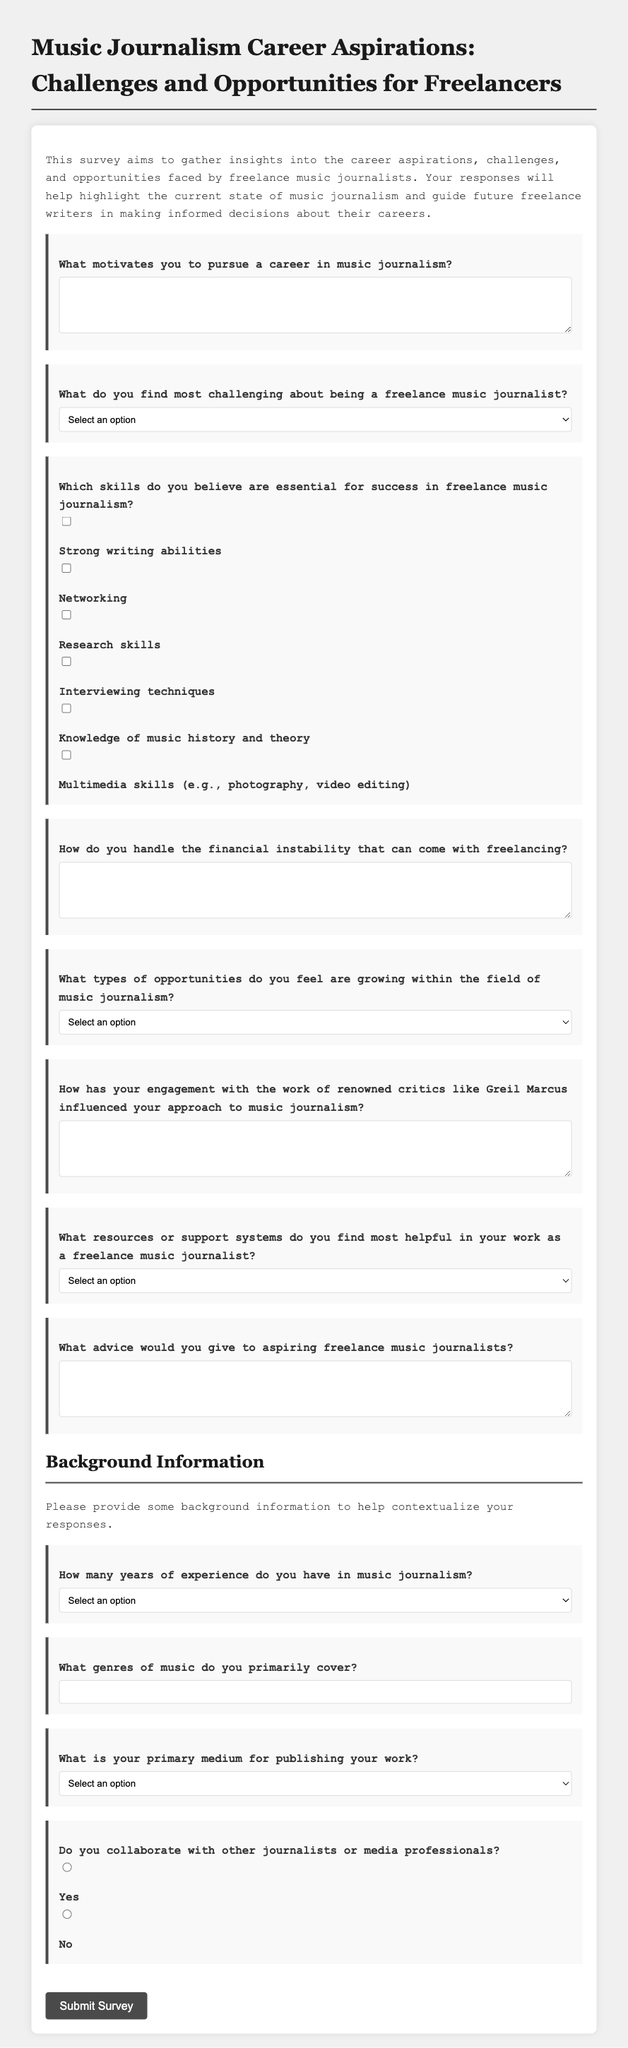What is the title of the survey? The title of the survey is provided in the document's heading section.
Answer: Music Journalism Career Aspirations: Challenges and Opportunities for Freelancers What is the purpose of the survey? The document states that the survey aims to gather insights regarding a specific topic.
Answer: To gather insights into the career aspirations, challenges, and opportunities faced by freelance music journalists How many years of experience options are listed in the survey? The document lists different options under the experience question.
Answer: Five What type of support systems do respondents have the option to select? The document includes a section under resources or support systems that provides various selections.
Answer: Writing workshops and courses, Professional networking events, Online communities and forums, Mentorship programs, Freelancer unions and guilds, Other What is one of the essential skills for success in freelance music journalism? The document lists multiple essential skills through checkboxes.
Answer: Strong writing abilities What motivates individuals to pursue music journalism? Respondents are prompted to provide their motivation within a specific section.
Answer: Open-ended response in a text area What is the primary medium for publishing work options? The survey contains a selection of mediums for publishing work.
Answer: Online publications, Print magazines/newspapers, Blogs, Podcasts, Social media, Other What kind of relationship do freelancers have with other journalists? The survey includes a question about collaboration with other professionals.
Answer: Yes or No options 